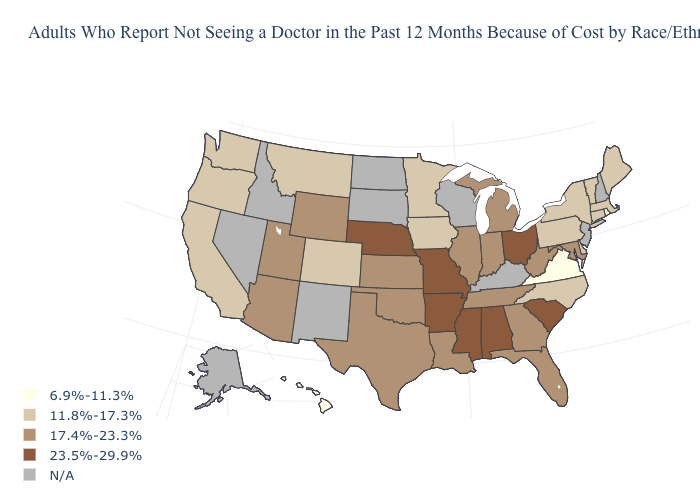Does Hawaii have the lowest value in the West?
Keep it brief. Yes. Which states have the highest value in the USA?
Give a very brief answer. Alabama, Arkansas, Mississippi, Missouri, Nebraska, Ohio, South Carolina. Name the states that have a value in the range N/A?
Concise answer only. Alaska, Idaho, Kentucky, Nevada, New Hampshire, New Jersey, New Mexico, North Dakota, South Dakota, Wisconsin. Which states have the highest value in the USA?
Give a very brief answer. Alabama, Arkansas, Mississippi, Missouri, Nebraska, Ohio, South Carolina. What is the highest value in the MidWest ?
Short answer required. 23.5%-29.9%. What is the value of Hawaii?
Give a very brief answer. 6.9%-11.3%. Name the states that have a value in the range 6.9%-11.3%?
Concise answer only. Hawaii, Rhode Island, Virginia. Name the states that have a value in the range 11.8%-17.3%?
Be succinct. California, Colorado, Connecticut, Delaware, Iowa, Maine, Massachusetts, Minnesota, Montana, New York, North Carolina, Oregon, Pennsylvania, Vermont, Washington. Name the states that have a value in the range 6.9%-11.3%?
Write a very short answer. Hawaii, Rhode Island, Virginia. What is the value of Massachusetts?
Concise answer only. 11.8%-17.3%. Does Colorado have the lowest value in the USA?
Short answer required. No. Does the first symbol in the legend represent the smallest category?
Answer briefly. Yes. Among the states that border Missouri , does Arkansas have the lowest value?
Short answer required. No. 